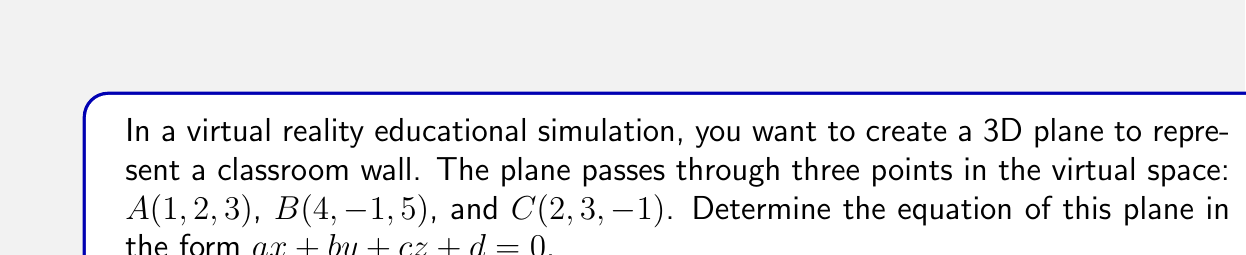Can you solve this math problem? To find the equation of a plane passing through three points, we can follow these steps:

1) First, we need to find two vectors on the plane. We can do this by subtracting the coordinates of two points from the third:

   $\vec{AB} = B - A = (4-1, -1-2, 5-3) = (3, -3, 2)$
   $\vec{AC} = C - A = (2-1, 3-2, -1-3) = (1, 1, -4)$

2) The normal vector to the plane will be the cross product of these two vectors:

   $\vec{n} = \vec{AB} \times \vec{AC}$

   $\vec{n} = \begin{vmatrix} 
   i & j & k \\
   3 & -3 & 2 \\
   1 & 1 & -4
   \end{vmatrix}$

   $\vec{n} = ((-3)(-4) - (2)(1))i - ((3)(-4) - (2)(1))j + ((3)(1) - (-3)(1))k$

   $\vec{n} = (12 - 2)i - (-12 - 2)j + (3 + 3)k$

   $\vec{n} = 10i + 10j + 6k$

3) The equation of the plane will be of the form:

   $a(x - x_1) + b(y - y_1) + c(z - z_1) = 0$

   where $(a, b, c)$ is the normal vector and $(x_1, y_1, z_1)$ is any point on the plane.

4) Substituting the components of the normal vector and the coordinates of point A:

   $10(x - 1) + 10(y - 2) + 6(z - 3) = 0$

5) Expanding the brackets:

   $10x - 10 + 10y - 20 + 6z - 18 = 0$

6) Rearranging to standard form $ax + by + cz + d = 0$:

   $10x + 10y + 6z - 48 = 0$
Answer: $10x + 10y + 6z - 48 = 0$ 